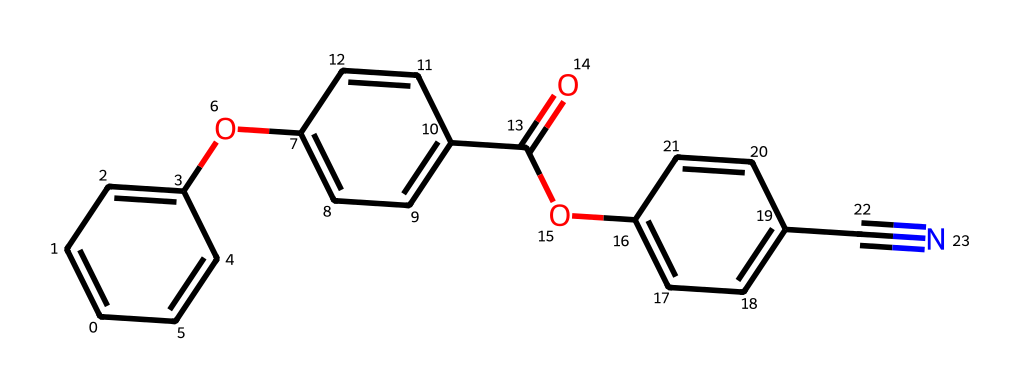What is the functional group present in this molecule? The molecule has an ether (-O-) and an ester (C(=O)O) as apparent functional groups. The ether is bonded to aromatic rings, and the ester is present between aromatic rings.
Answer: ether and ester How many aromatic rings are present in the structure? The SMILES notation reveals three aromatic rings; each 'c' denotes a carbon in an aromatic ring. Counting those that form closed loops indicates three distinct aromatic groups.
Answer: 3 What type of bonding is primarily responsible for the stability of the aromatic rings? The stability of aromatic rings is primarily due to resonance, where electrons are delocalized across the carbon atoms of the ring, creating a stable electron cloud above and below the plane of the ring.
Answer: resonance What heteroatom is included in the structure, and where is it located? The molecule contains an oxygen atom (O), which can be found in both the ether and ester functional groups. This heteroatom is crucial for the molecule's properties.
Answer: oxygen What is the total number of carbon atoms in the entire molecule? By analyzing the SMILES, you count all carbon atoms represented; there are a total of 15 carbon (c) atoms in the described structure.
Answer: 15 How do the aromatic rings influence the solubility of this compound? Aromatic rings tend to increase hydrophobic characteristics, making the compound less soluble in water, as they repel polar solvents. The functional groups, like the ester, can increase solubility to some extent, but the overall effect leans towards hydrophobicity due to the dominant presence of aromatic systems.
Answer: hydrophobicity What type of reagent would best react with the cyano group (C#N) in this compound? The cyano group (C#N) is polar and can react well with nucleophiles. Thus, a good reagent to react with this group would be a nucleophilic agent like sodium azide or Grignard reagents, which can attack the carbon of the cyano group and make it more reactive.
Answer: nucleophilic agents 